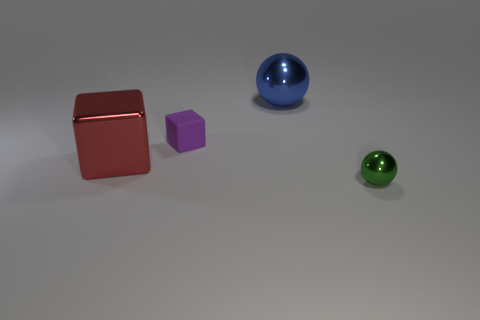Add 1 big red metallic things. How many objects exist? 5 Add 4 blue objects. How many blue objects exist? 5 Subtract 0 red balls. How many objects are left? 4 Subtract all big gray matte objects. Subtract all tiny purple rubber blocks. How many objects are left? 3 Add 1 purple matte objects. How many purple matte objects are left? 2 